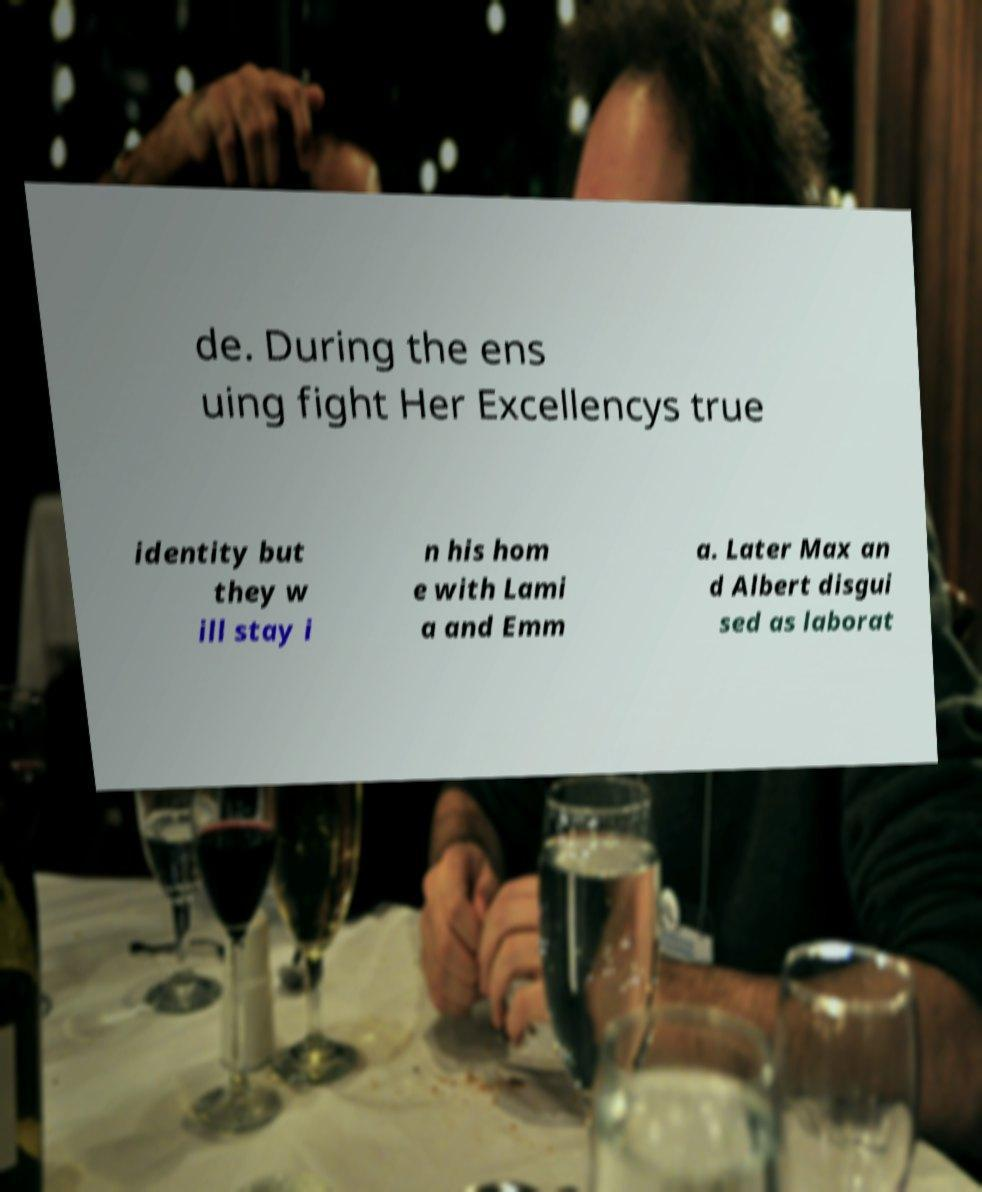Can you accurately transcribe the text from the provided image for me? de. During the ens uing fight Her Excellencys true identity but they w ill stay i n his hom e with Lami a and Emm a. Later Max an d Albert disgui sed as laborat 